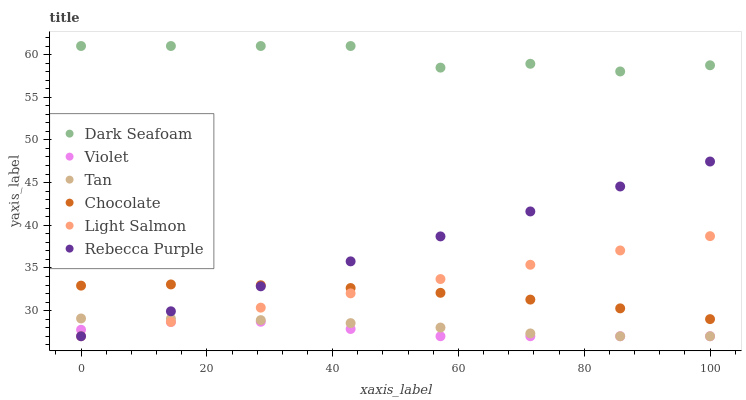Does Violet have the minimum area under the curve?
Answer yes or no. Yes. Does Dark Seafoam have the maximum area under the curve?
Answer yes or no. Yes. Does Chocolate have the minimum area under the curve?
Answer yes or no. No. Does Chocolate have the maximum area under the curve?
Answer yes or no. No. Is Rebecca Purple the smoothest?
Answer yes or no. Yes. Is Dark Seafoam the roughest?
Answer yes or no. Yes. Is Chocolate the smoothest?
Answer yes or no. No. Is Chocolate the roughest?
Answer yes or no. No. Does Light Salmon have the lowest value?
Answer yes or no. Yes. Does Chocolate have the lowest value?
Answer yes or no. No. Does Dark Seafoam have the highest value?
Answer yes or no. Yes. Does Chocolate have the highest value?
Answer yes or no. No. Is Tan less than Dark Seafoam?
Answer yes or no. Yes. Is Dark Seafoam greater than Light Salmon?
Answer yes or no. Yes. Does Light Salmon intersect Tan?
Answer yes or no. Yes. Is Light Salmon less than Tan?
Answer yes or no. No. Is Light Salmon greater than Tan?
Answer yes or no. No. Does Tan intersect Dark Seafoam?
Answer yes or no. No. 